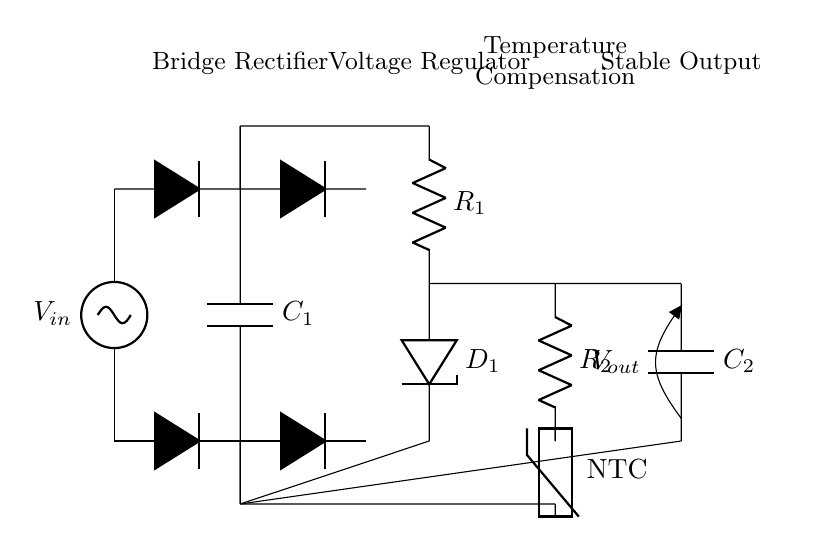What is the purpose of the smoothing capacitor? The smoothing capacitor is used to reduce voltage fluctuations and improve the DC output's consistency after rectification. In this circuit, it's labeled as C1 and is connected in parallel with the output to stabilize the voltage.
Answer: Reducing voltage fluctuations What type of rectifier is shown in the circuit? The circuit employs a bridge rectifier configuration. This is indicated by the arrangement of four diodes that convert AC input to DC output.
Answer: Bridge rectifier What component is used for temperature compensation? The temperature compensation in this circuit is achieved through the use of a thermistor, specifically an NTC (Negative Temperature Coefficient) device which alters its resistance based on temperature changes.
Answer: NTC What is the output voltage indicated in the diagram? The output voltage is labeled as Vout at the end of the circuit diagram. This is a standard indicator for the voltage available from the rectifier after processing the input AC voltage.
Answer: Vout Which component regulates the voltage after rectification? The voltage regulator is the component that maintains a constant output voltage level. In the circuit, it is represented by the resistor R1 in combination with the diode D1, ensuring regulation of the DC output.
Answer: Voltage regulator What happens to the voltage as it passes through the diodes? The voltage drops due to the forward voltage drop across the diodes in the rectifier. Each diode contributes to reducing the overall output voltage, which is visible in the schematic.
Answer: Voltage drop How many diodes are used in the bridge rectifier? There are four diodes used in the bridge rectifier configuration, as shown in the circuit where they are connected to alternate AC inputs and outputs, enabling full-wave rectification.
Answer: Four diodes 